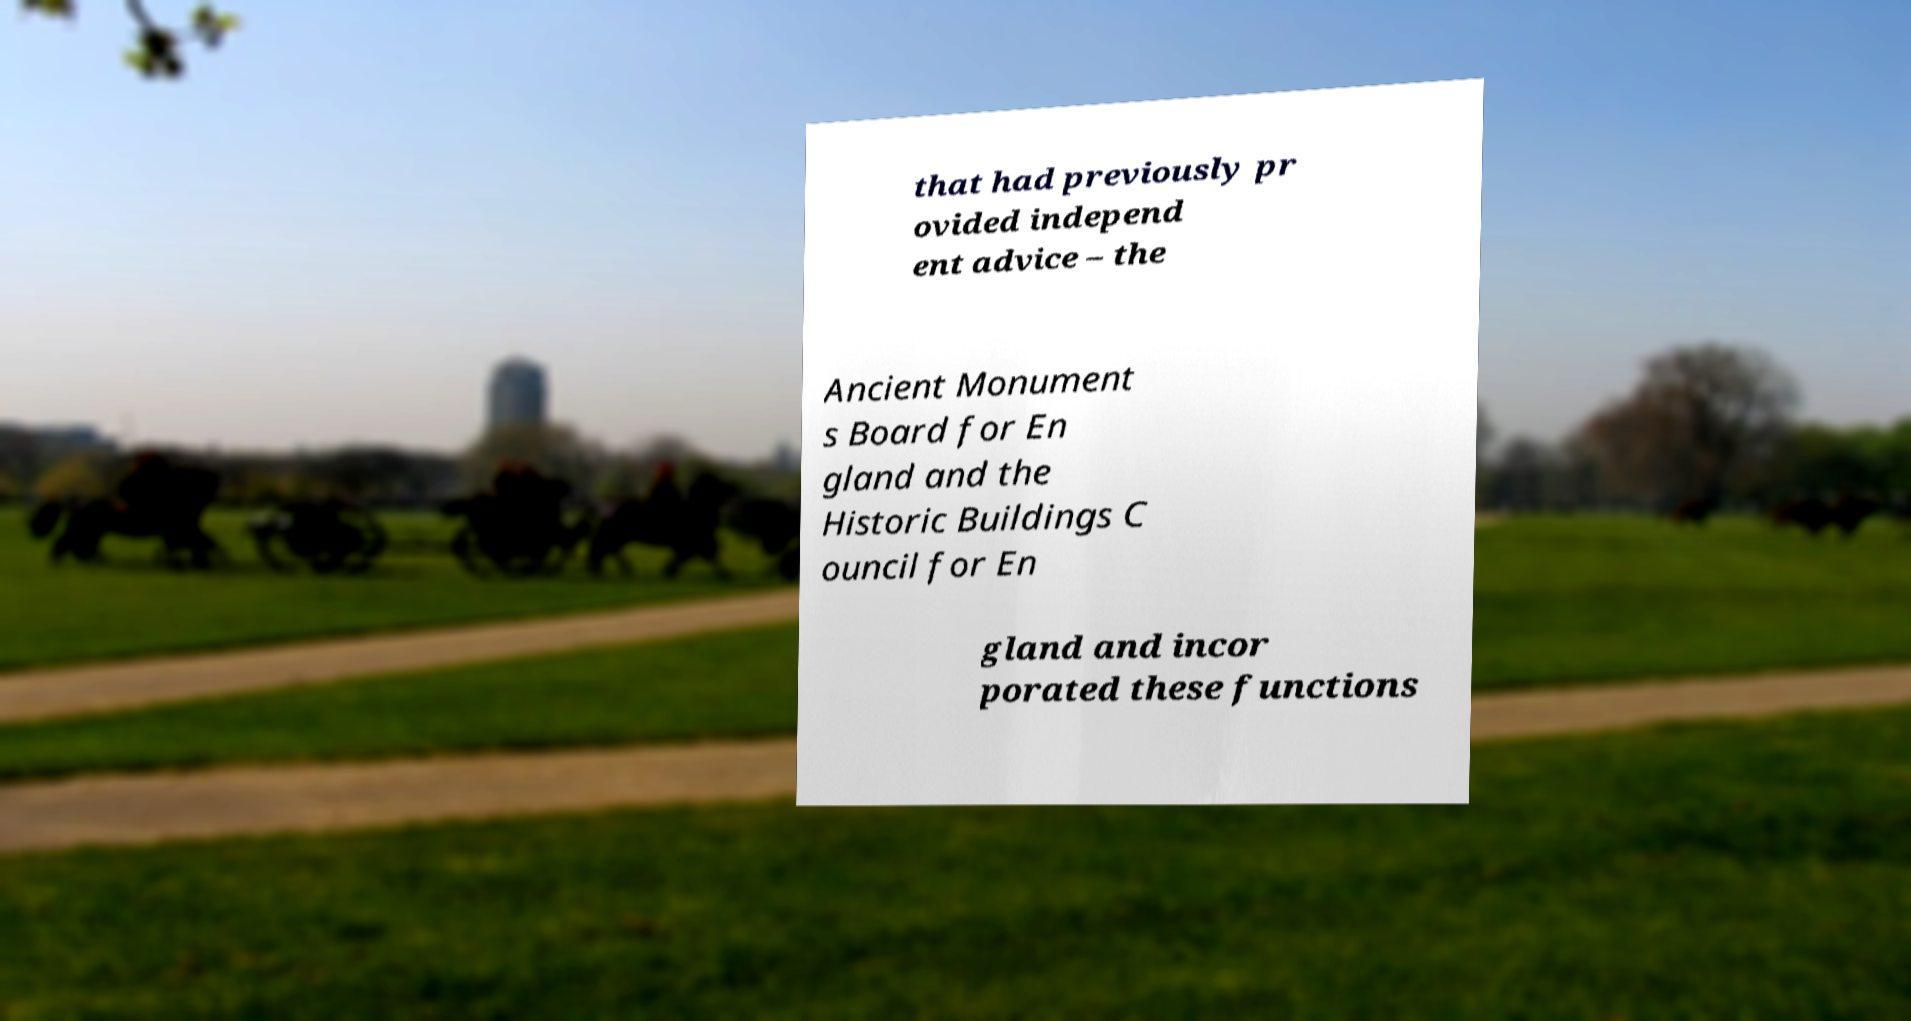Could you extract and type out the text from this image? that had previously pr ovided independ ent advice – the Ancient Monument s Board for En gland and the Historic Buildings C ouncil for En gland and incor porated these functions 